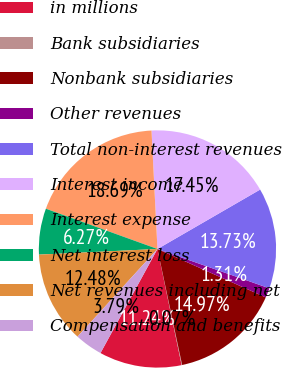<chart> <loc_0><loc_0><loc_500><loc_500><pie_chart><fcel>in millions<fcel>Bank subsidiaries<fcel>Nonbank subsidiaries<fcel>Other revenues<fcel>Total non-interest revenues<fcel>Interest income<fcel>Interest expense<fcel>Net interest loss<fcel>Net revenues including net<fcel>Compensation and benefits<nl><fcel>11.24%<fcel>0.07%<fcel>14.97%<fcel>1.31%<fcel>13.73%<fcel>17.45%<fcel>18.69%<fcel>6.27%<fcel>12.48%<fcel>3.79%<nl></chart> 